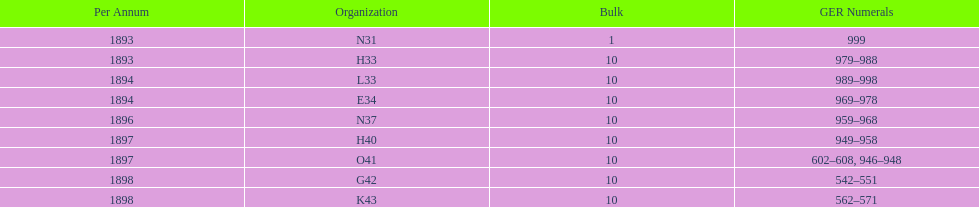Were there more n31 or e34 ordered? E34. Could you parse the entire table? {'header': ['Per Annum', 'Organization', 'Bulk', 'GER Numerals'], 'rows': [['1893', 'N31', '1', '999'], ['1893', 'H33', '10', '979–988'], ['1894', 'L33', '10', '989–998'], ['1894', 'E34', '10', '969–978'], ['1896', 'N37', '10', '959–968'], ['1897', 'H40', '10', '949–958'], ['1897', 'O41', '10', '602–608, 946–948'], ['1898', 'G42', '10', '542–551'], ['1898', 'K43', '10', '562–571']]} 